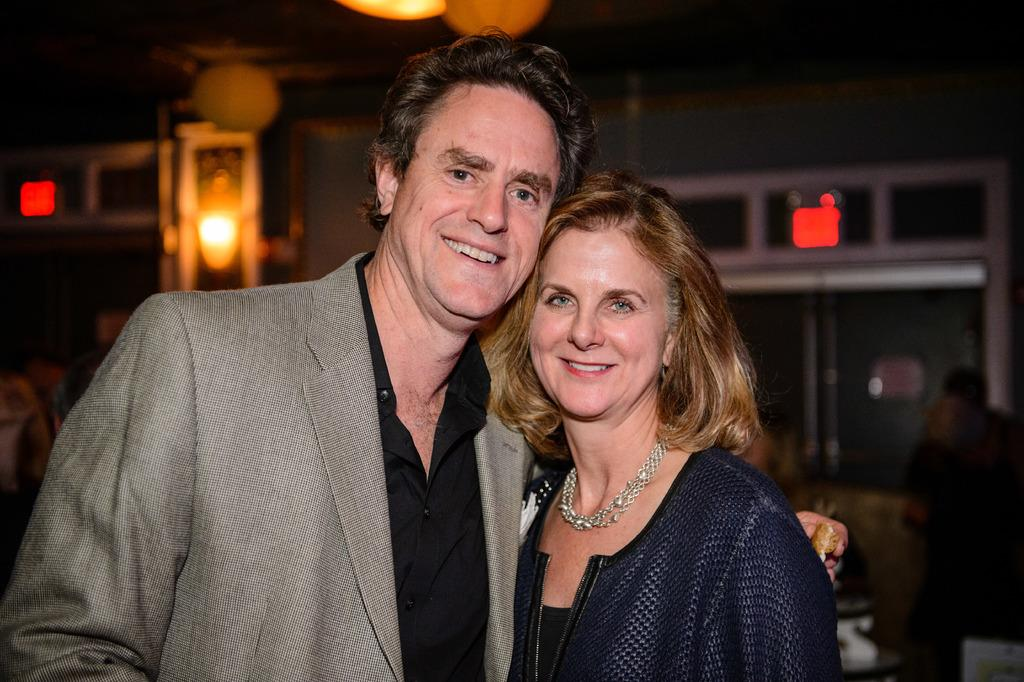How many people are present in the image? There are two people, a man and a woman, present in the image. What are the man and woman doing in the image? Both the man and woman are standing and smiling. What can be seen in the background of the image? The background of the image appears blurry. What is visible in the image besides the man and woman? There are lights visible in the image. Can you tell me how many cactus plants are present in the image? There are no cactus plants present in the image. What type of spark can be seen in the image? There is no spark visible in the image. 